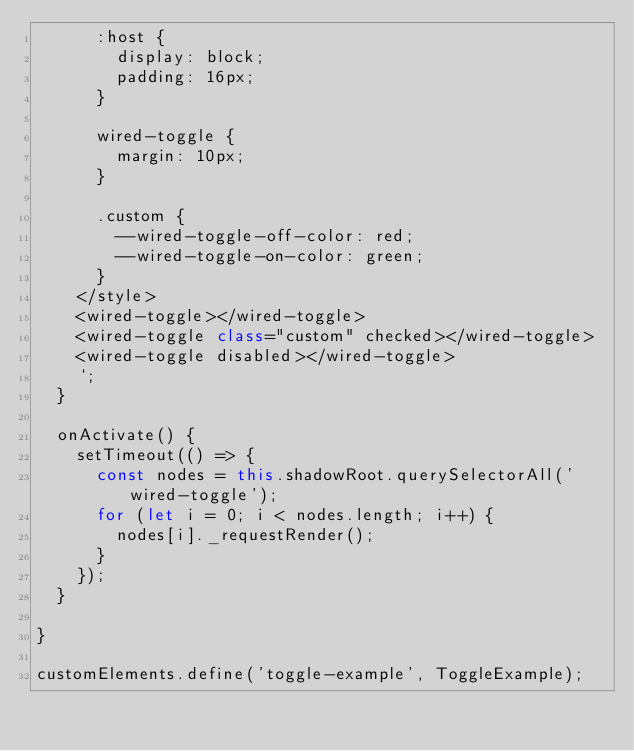<code> <loc_0><loc_0><loc_500><loc_500><_JavaScript_>      :host {
        display: block;
        padding: 16px;
      }
    
      wired-toggle {
        margin: 10px;
      }
    
      .custom {
        --wired-toggle-off-color: red;
        --wired-toggle-on-color: green;
      }
    </style>
    <wired-toggle></wired-toggle>
    <wired-toggle class="custom" checked></wired-toggle>
    <wired-toggle disabled></wired-toggle>
    `;
  }

  onActivate() {
    setTimeout(() => {
      const nodes = this.shadowRoot.querySelectorAll('wired-toggle');
      for (let i = 0; i < nodes.length; i++) {
        nodes[i]._requestRender();
      }
    });
  }

}

customElements.define('toggle-example', ToggleExample);</code> 